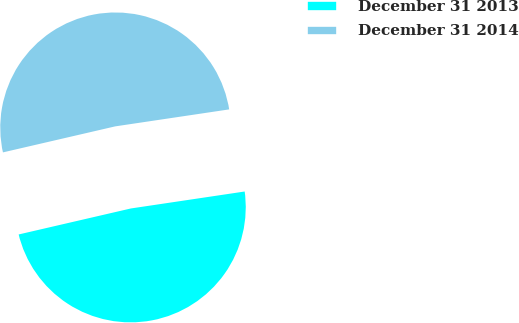Convert chart to OTSL. <chart><loc_0><loc_0><loc_500><loc_500><pie_chart><fcel>December 31 2013<fcel>December 31 2014<nl><fcel>48.73%<fcel>51.27%<nl></chart> 